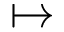Convert formula to latex. <formula><loc_0><loc_0><loc_500><loc_500>\mapsto</formula> 